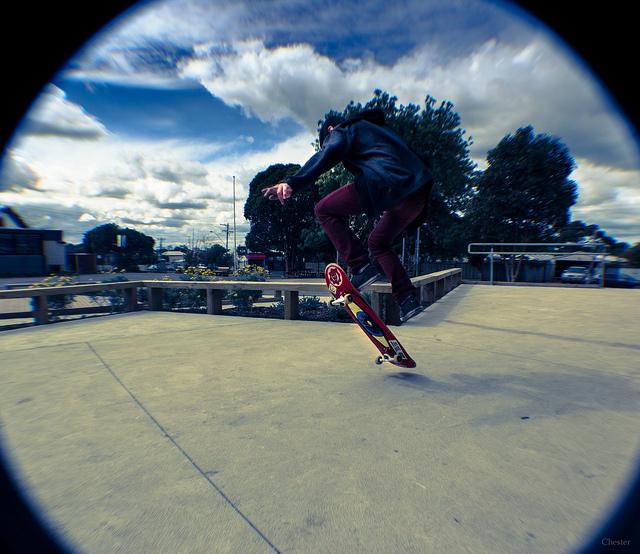Why does this man look so distorted in the photo?
Write a very short answer. Type of lens. What color is the skateboard?
Keep it brief. Red. What type of camera lens takes this kind of picture?
Write a very short answer. Fisheye. What kind of trick is he doing?
Give a very brief answer. Jump. Is the kid sitting on the bus?
Write a very short answer. No. 